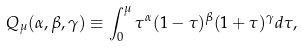Convert formula to latex. <formula><loc_0><loc_0><loc_500><loc_500>Q _ { \mu } ( \alpha , \beta , \gamma ) \equiv \int _ { 0 } ^ { \mu } \tau ^ { \alpha } ( 1 - \tau ) ^ { \beta } ( 1 + \tau ) ^ { \gamma } d \tau ,</formula> 